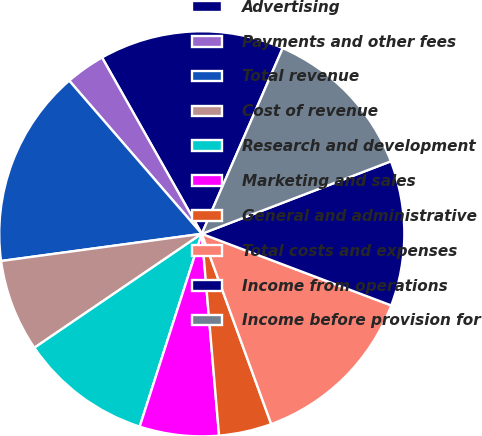Convert chart to OTSL. <chart><loc_0><loc_0><loc_500><loc_500><pie_chart><fcel>Advertising<fcel>Payments and other fees<fcel>Total revenue<fcel>Cost of revenue<fcel>Research and development<fcel>Marketing and sales<fcel>General and administrative<fcel>Total costs and expenses<fcel>Income from operations<fcel>Income before provision for<nl><fcel>14.74%<fcel>3.16%<fcel>15.79%<fcel>7.37%<fcel>10.53%<fcel>6.32%<fcel>4.21%<fcel>13.68%<fcel>11.58%<fcel>12.63%<nl></chart> 